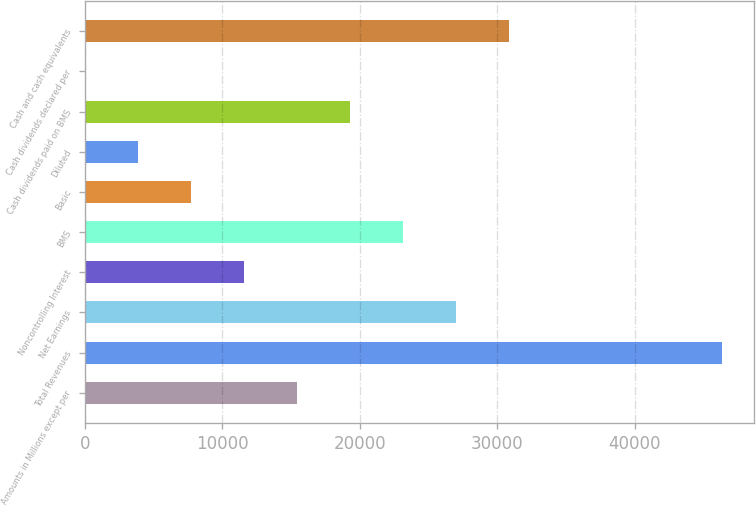Convert chart to OTSL. <chart><loc_0><loc_0><loc_500><loc_500><bar_chart><fcel>Amounts in Millions except per<fcel>Total Revenues<fcel>Net Earnings<fcel>Noncontrolling Interest<fcel>BMS<fcel>Basic<fcel>Diluted<fcel>Cash dividends paid on BMS<fcel>Cash dividends declared per<fcel>Cash and cash equivalents<nl><fcel>15437.6<fcel>46310.1<fcel>27014.8<fcel>11578.6<fcel>23155.8<fcel>7719.53<fcel>3860.47<fcel>19296.7<fcel>1.41<fcel>30873.9<nl></chart> 